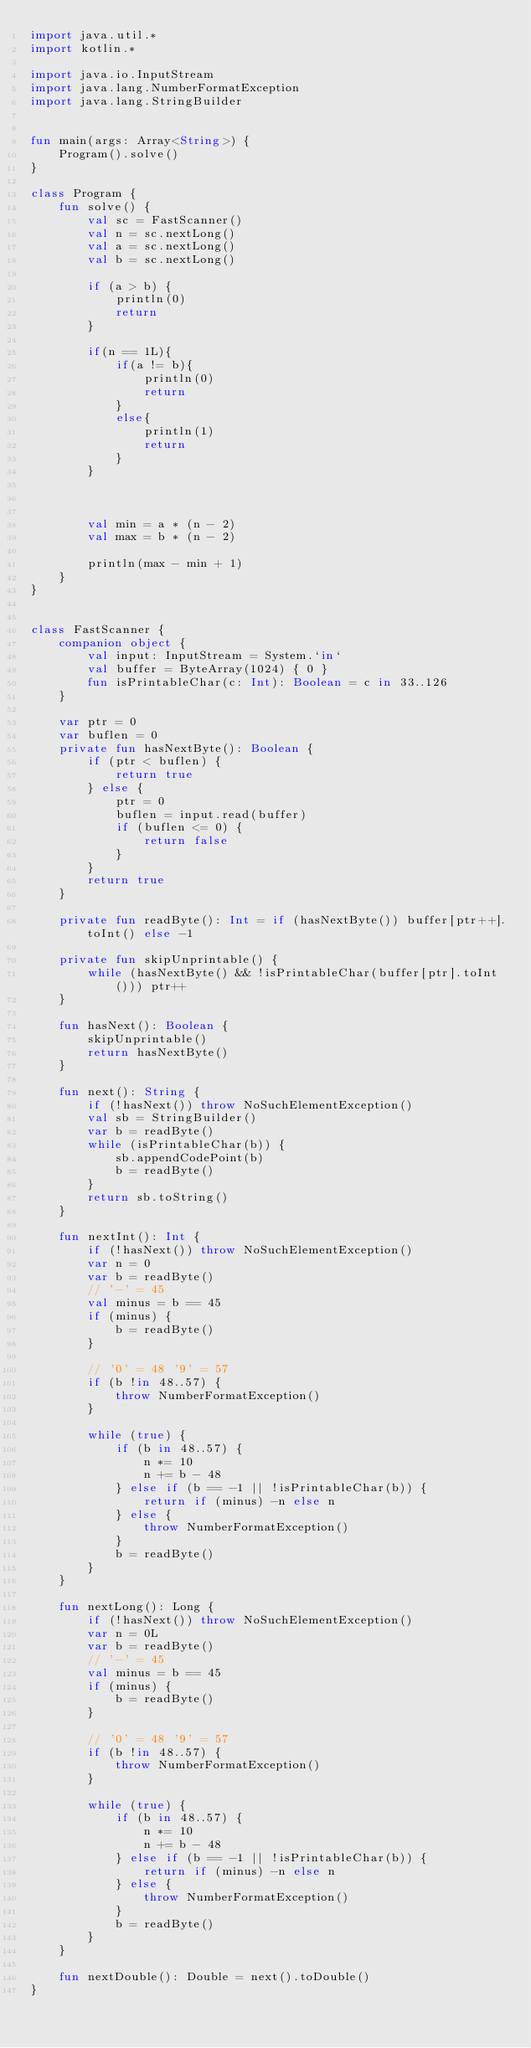<code> <loc_0><loc_0><loc_500><loc_500><_Kotlin_>import java.util.*
import kotlin.*

import java.io.InputStream
import java.lang.NumberFormatException
import java.lang.StringBuilder


fun main(args: Array<String>) {
    Program().solve()
}

class Program {
    fun solve() {
        val sc = FastScanner()
        val n = sc.nextLong()
        val a = sc.nextLong()
        val b = sc.nextLong()

        if (a > b) {
            println(0)
            return
        }

        if(n == 1L){
            if(a != b){
                println(0)
                return
            }
            else{
                println(1)
                return
            }
        }



        val min = a * (n - 2)
        val max = b * (n - 2)

        println(max - min + 1)
    }
}


class FastScanner {
    companion object {
        val input: InputStream = System.`in`
        val buffer = ByteArray(1024) { 0 }
        fun isPrintableChar(c: Int): Boolean = c in 33..126
    }

    var ptr = 0
    var buflen = 0
    private fun hasNextByte(): Boolean {
        if (ptr < buflen) {
            return true
        } else {
            ptr = 0
            buflen = input.read(buffer)
            if (buflen <= 0) {
                return false
            }
        }
        return true
    }

    private fun readByte(): Int = if (hasNextByte()) buffer[ptr++].toInt() else -1

    private fun skipUnprintable() {
        while (hasNextByte() && !isPrintableChar(buffer[ptr].toInt())) ptr++
    }

    fun hasNext(): Boolean {
        skipUnprintable()
        return hasNextByte()
    }

    fun next(): String {
        if (!hasNext()) throw NoSuchElementException()
        val sb = StringBuilder()
        var b = readByte()
        while (isPrintableChar(b)) {
            sb.appendCodePoint(b)
            b = readByte()
        }
        return sb.toString()
    }

    fun nextInt(): Int {
        if (!hasNext()) throw NoSuchElementException()
        var n = 0
        var b = readByte()
        // '-' = 45
        val minus = b == 45
        if (minus) {
            b = readByte()
        }

        // '0' = 48 '9' = 57
        if (b !in 48..57) {
            throw NumberFormatException()
        }

        while (true) {
            if (b in 48..57) {
                n *= 10
                n += b - 48
            } else if (b == -1 || !isPrintableChar(b)) {
                return if (minus) -n else n
            } else {
                throw NumberFormatException()
            }
            b = readByte()
        }
    }

    fun nextLong(): Long {
        if (!hasNext()) throw NoSuchElementException()
        var n = 0L
        var b = readByte()
        // '-' = 45
        val minus = b == 45
        if (minus) {
            b = readByte()
        }

        // '0' = 48 '9' = 57
        if (b !in 48..57) {
            throw NumberFormatException()
        }

        while (true) {
            if (b in 48..57) {
                n *= 10
                n += b - 48
            } else if (b == -1 || !isPrintableChar(b)) {
                return if (minus) -n else n
            } else {
                throw NumberFormatException()
            }
            b = readByte()
        }
    }

    fun nextDouble(): Double = next().toDouble()
}
</code> 